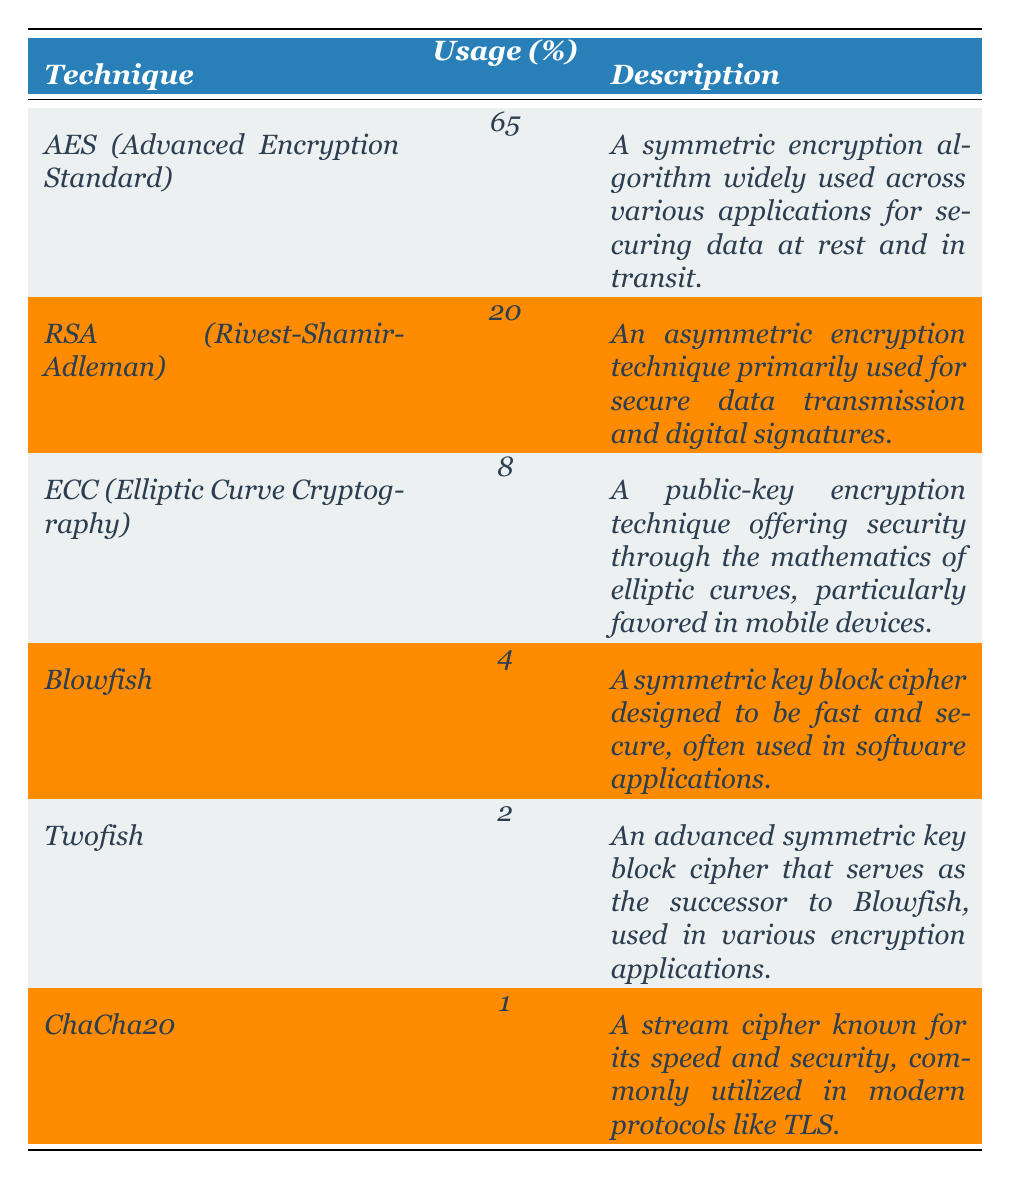What is the usage percentage of AES? The table shows that AES (Advanced Encryption Standard) has a usage percentage of 65%.
Answer: 65% Which cipher technique has the least usage percentage? Looking at the table, ChaCha20 has the least usage percentage at 1%.
Answer: 1% What is the combined usage percentage of RSA and ECC? To find the combined percentage of RSA (20%) and ECC (8%), we add them together: 20 + 8 = 28%.
Answer: 28% Is Blowfish utilized more than Twofish? Yes, since Blowfish has a usage percentage of 4% and Twofish has 2%.
Answer: Yes Which technique is primarily used for secure digital signatures? RSA (Rivest-Shamir-Adleman) is primarily used for secure digital signatures as stated in the description.
Answer: RSA What percentage of contemporary encryption methods use symmetric encryption algorithms? The symmetric techniques are AES (65%) and Blowfish (4%), so we sum those percentages: 65 + 4 = 69%.
Answer: 69% What is the difference in usage percentage between AES and RSA? AES has 65% usage while RSA has 20%; thus, the difference is 65 - 20 = 45%.
Answer: 45% If we grouped ECC, Blowfish, Twofish, and ChaCha20 together, what would be the combined usage percentage? Adding their usage percentages: ECC (8%) + Blowfish (4%) + Twofish (2%) + ChaCha20 (1%) gives us 8 + 4 + 2 + 1 = 15%.
Answer: 15% Which encryption technique predominately secures data during transmission? RSA (Rivest-Shamir-Adleman) is primarily utilized for secure data transmission, as indicated in its description.
Answer: RSA How many cipher techniques listed have a usage percentage of 5% or less? The techniques with 5% or less are Twofish (2%) and ChaCha20 (1%), totaling two techniques in this category.
Answer: 2 